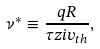<formula> <loc_0><loc_0><loc_500><loc_500>\nu ^ { * } \equiv \frac { q R } { \tau z i v _ { t h } } ,</formula> 